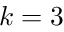Convert formula to latex. <formula><loc_0><loc_0><loc_500><loc_500>k = 3</formula> 